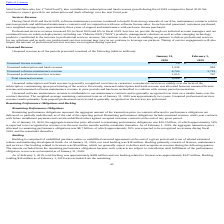According to Vmware's financial document, What was unearned software maintenance revenue attributable to? maintenance contracts and is generally recognized over time on a ratable basis over the contract duration.. The document states: "oftware maintenance revenue is attributable to our maintenance contracts and is generally recognized over time on a ratable basis over the contract du..." Also, What was unearned professional services revenue a result of? prepaid professional services and is generally recognized as the services are performed.. The document states: "ofessional services revenue results primarily from prepaid professional services and is generally recognized as the services are performed...." Also, Which years does the table provide information for unearned revenue? The document shows two values: 2020 and 2019. From the document: "ubscription and SaaS revenue growth during fiscal 2019 compared to fiscal 2018. We continue to expect growth in our subscription and SaaS offerings ov..." Also, can you calculate: What was the change in Unearned subscription and SaaS revenue between 2019 and 2020? Based on the calculation: 1,534-916, the result is 618 (in millions). This is based on the information: "Unearned subscription and SaaS revenue 1,534 916 Unearned subscription and SaaS revenue 1,534 916..." The key data points involved are: 1,534, 916. Also, How many years did Unearned software maintenance revenue exceed $5,000 million? Counting the relevant items in the document: 2020, 2019, I find 2 instances. The key data points involved are: 2019, 2020. Also, can you calculate: What was the percentage change in total unearned revenue between 2019 and 2020? To answer this question, I need to perform calculations using the financial data. The calculation is: (9,268-7,439)/7,439, which equals 24.59 (percentage). This is based on the information: "Total unearned revenue $ 9,268 $ 7,439 Total unearned revenue $ 9,268 $ 7,439..." The key data points involved are: 7,439, 9,268. 